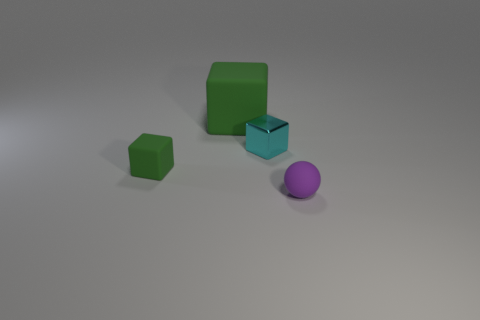What is the shape of the other rubber object that is the same color as the big object?
Your answer should be very brief. Cube. There is a large cube; is its color the same as the small rubber object that is on the left side of the small shiny block?
Your response must be concise. Yes. There is another block that is the same color as the small matte block; what is its size?
Offer a very short reply. Large. Do the large block and the tiny rubber block have the same color?
Provide a succinct answer. Yes. Is there a small thing of the same color as the big matte cube?
Provide a short and direct response. Yes. There is a purple rubber thing; is its size the same as the rubber thing behind the tiny metal thing?
Keep it short and to the point. No. There is a rubber thing that is both behind the purple object and in front of the large object; how big is it?
Give a very brief answer. Small. Is there a tiny green object that has the same material as the sphere?
Make the answer very short. Yes. The tiny green object is what shape?
Your answer should be compact. Cube. What number of other things are the same shape as the big green thing?
Your answer should be very brief. 2. 